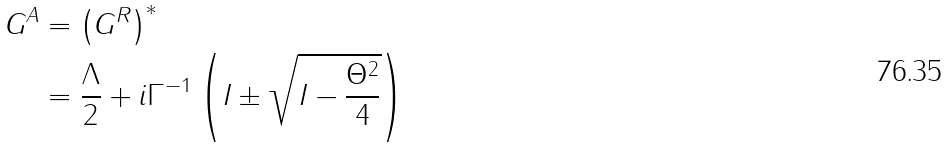Convert formula to latex. <formula><loc_0><loc_0><loc_500><loc_500>G ^ { A } & = \left ( G ^ { R } \right ) ^ { \ast } \\ & = \frac { \Lambda } { 2 } + i \Gamma ^ { - 1 } \left ( I \pm \sqrt { I - \frac { \Theta ^ { 2 } } { 4 } } \right )</formula> 